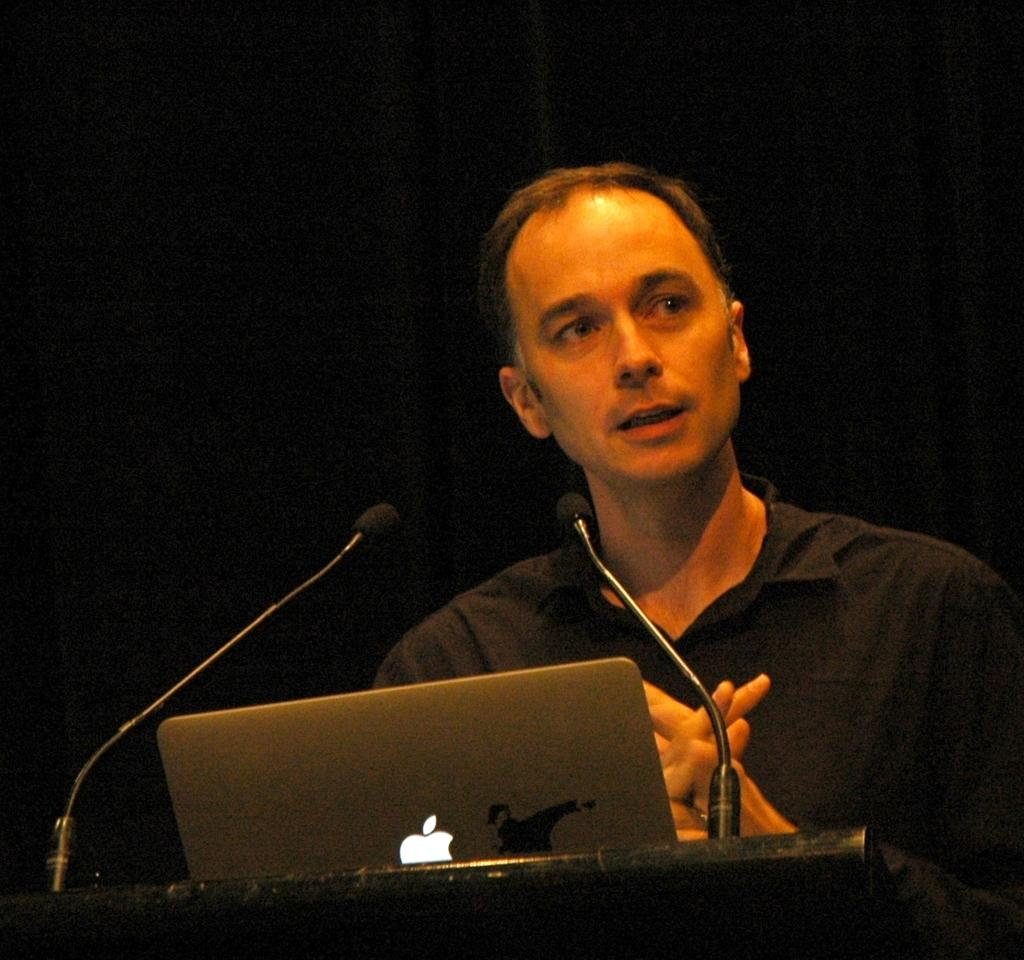What is the man in the image doing? The man is standing in the image. What is the man wearing? The man is wearing a black shirt. What object can be seen in the image that is typically used for public speaking? There is a podium in the image. What object can be seen in the image that is used for amplifying sound? There is a microphone in the image. What object can be seen in the image that is used for presentations or displaying information? There is a laptop in the image. What color is the background of the image? The background of the image is black. What type of brush is being used to decorate the cakes in the image? There are no cakes or brushes present in the image. 